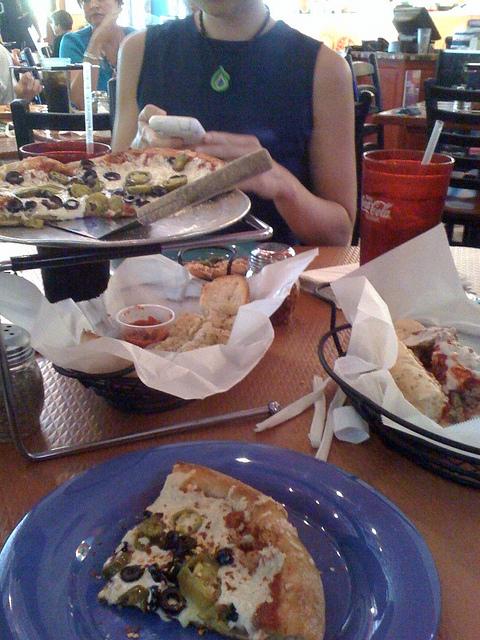What type of food is served on the table? The table seems to be filled with a variety of Italian-American cuisines, notably several slices of pizza with different toppings and a basket probably containing breadsticks or garlic bread, accompanied by small bowls of marinara sauce for dipping. 